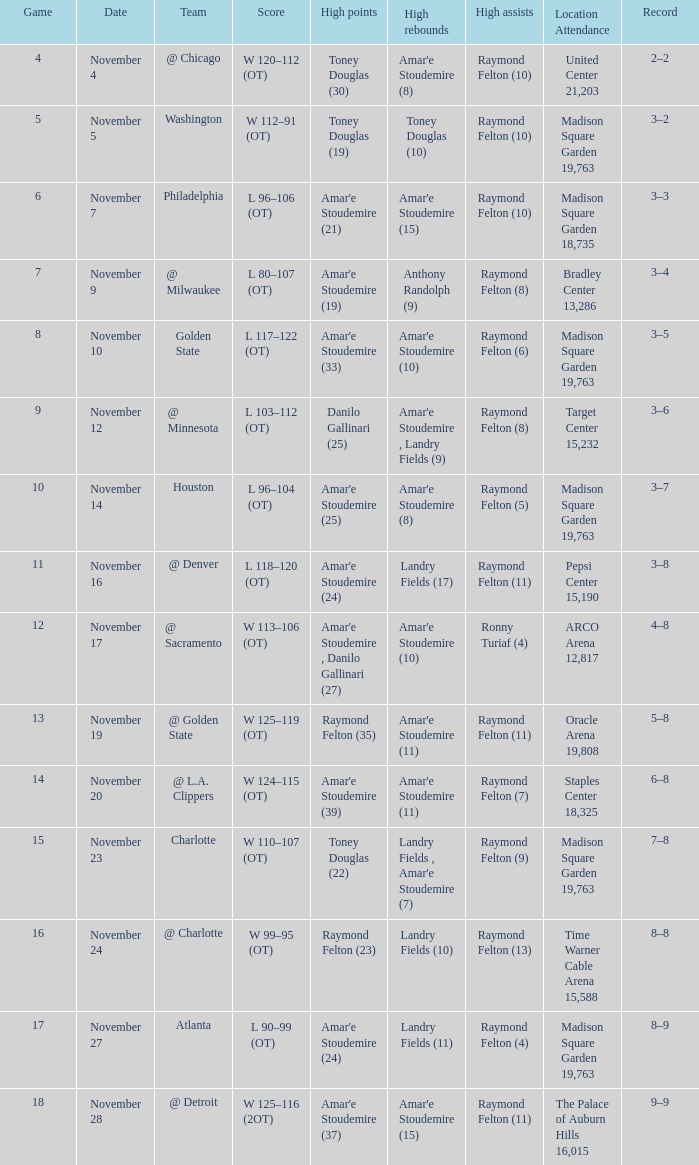What game number is the Washington team. 1.0. 